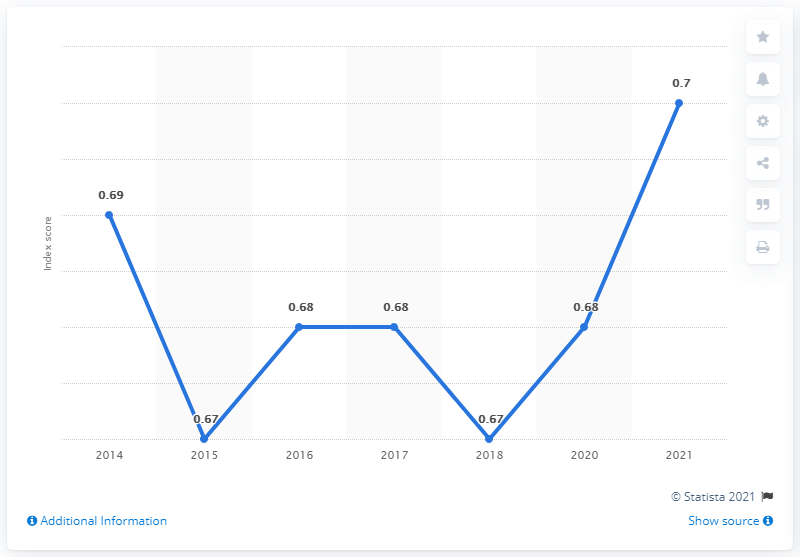Specify some key components in this picture. In 2021, Paraguay's gender gap index score was 0.7, indicating a moderate disparity between men and women in terms of their access to resources and opportunities. 